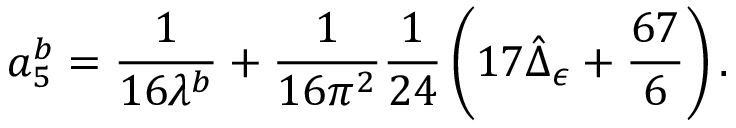<formula> <loc_0><loc_0><loc_500><loc_500>a _ { 5 } ^ { b } = \frac { 1 } { 1 6 \lambda ^ { b } } + \frac { 1 } { 1 6 \pi ^ { 2 } } \frac { 1 } { 2 4 } \left ( 1 7 \hat { \Delta } _ { \epsilon } + \frac { 6 7 } { 6 } \right ) .</formula> 